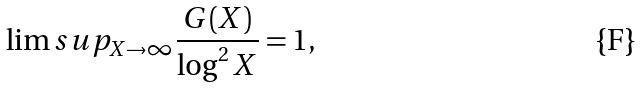<formula> <loc_0><loc_0><loc_500><loc_500>\lim s u p _ { X \to \infty } \frac { G ( X ) } { \log ^ { 2 } X } = 1 ,</formula> 